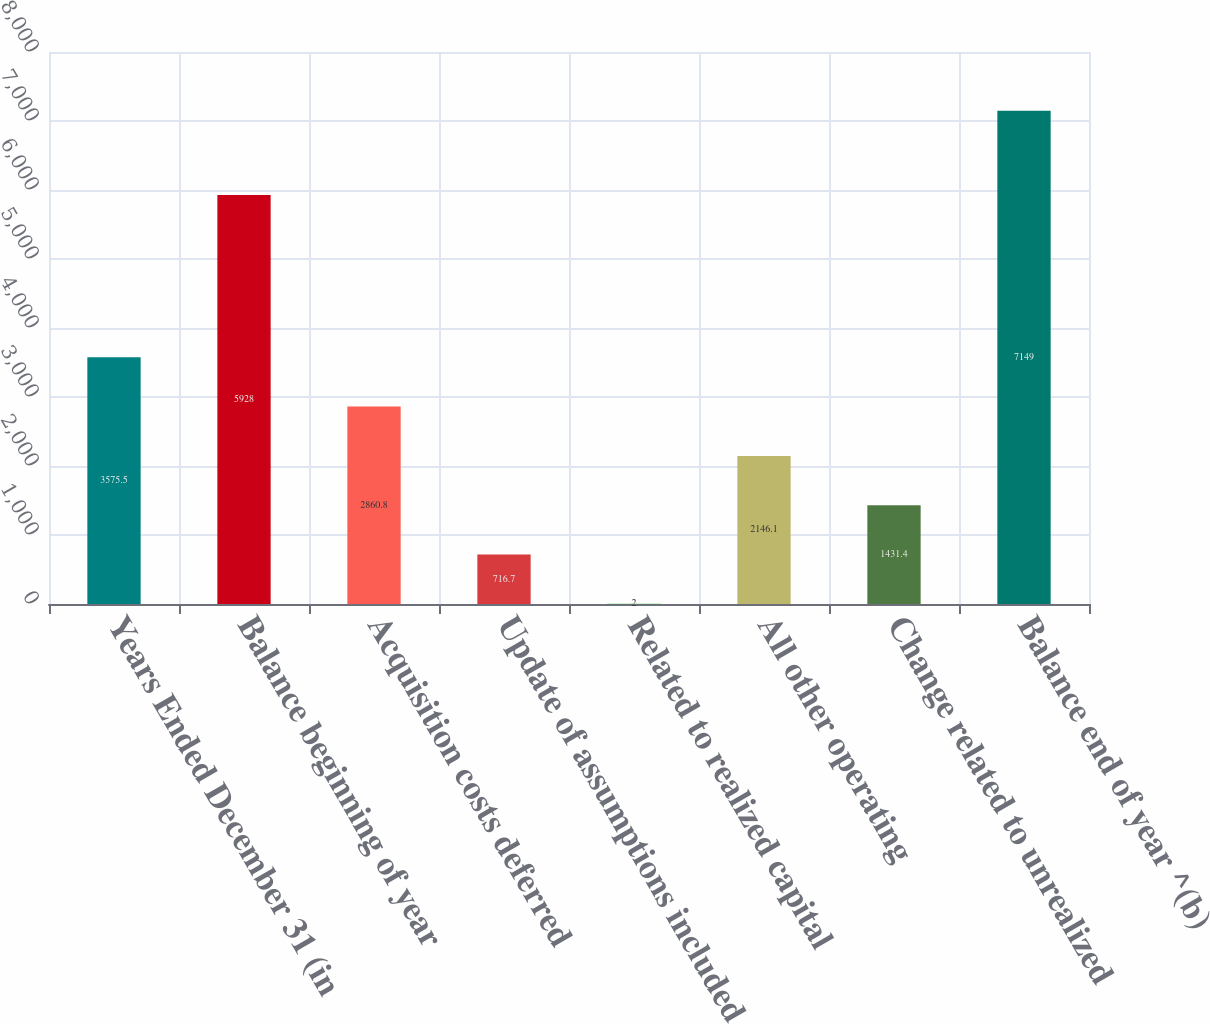<chart> <loc_0><loc_0><loc_500><loc_500><bar_chart><fcel>Years Ended December 31 (in<fcel>Balance beginning of year<fcel>Acquisition costs deferred<fcel>Update of assumptions included<fcel>Related to realized capital<fcel>All other operating<fcel>Change related to unrealized<fcel>Balance end of year ^(b)<nl><fcel>3575.5<fcel>5928<fcel>2860.8<fcel>716.7<fcel>2<fcel>2146.1<fcel>1431.4<fcel>7149<nl></chart> 